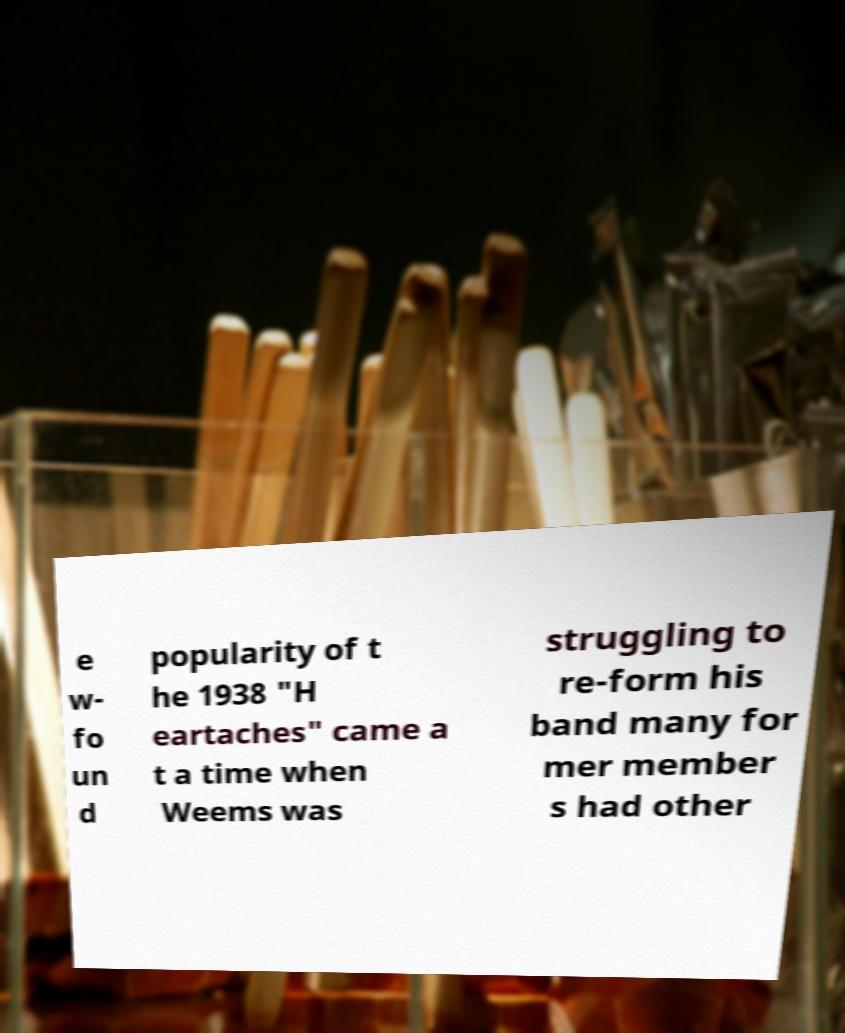Please identify and transcribe the text found in this image. e w- fo un d popularity of t he 1938 "H eartaches" came a t a time when Weems was struggling to re-form his band many for mer member s had other 